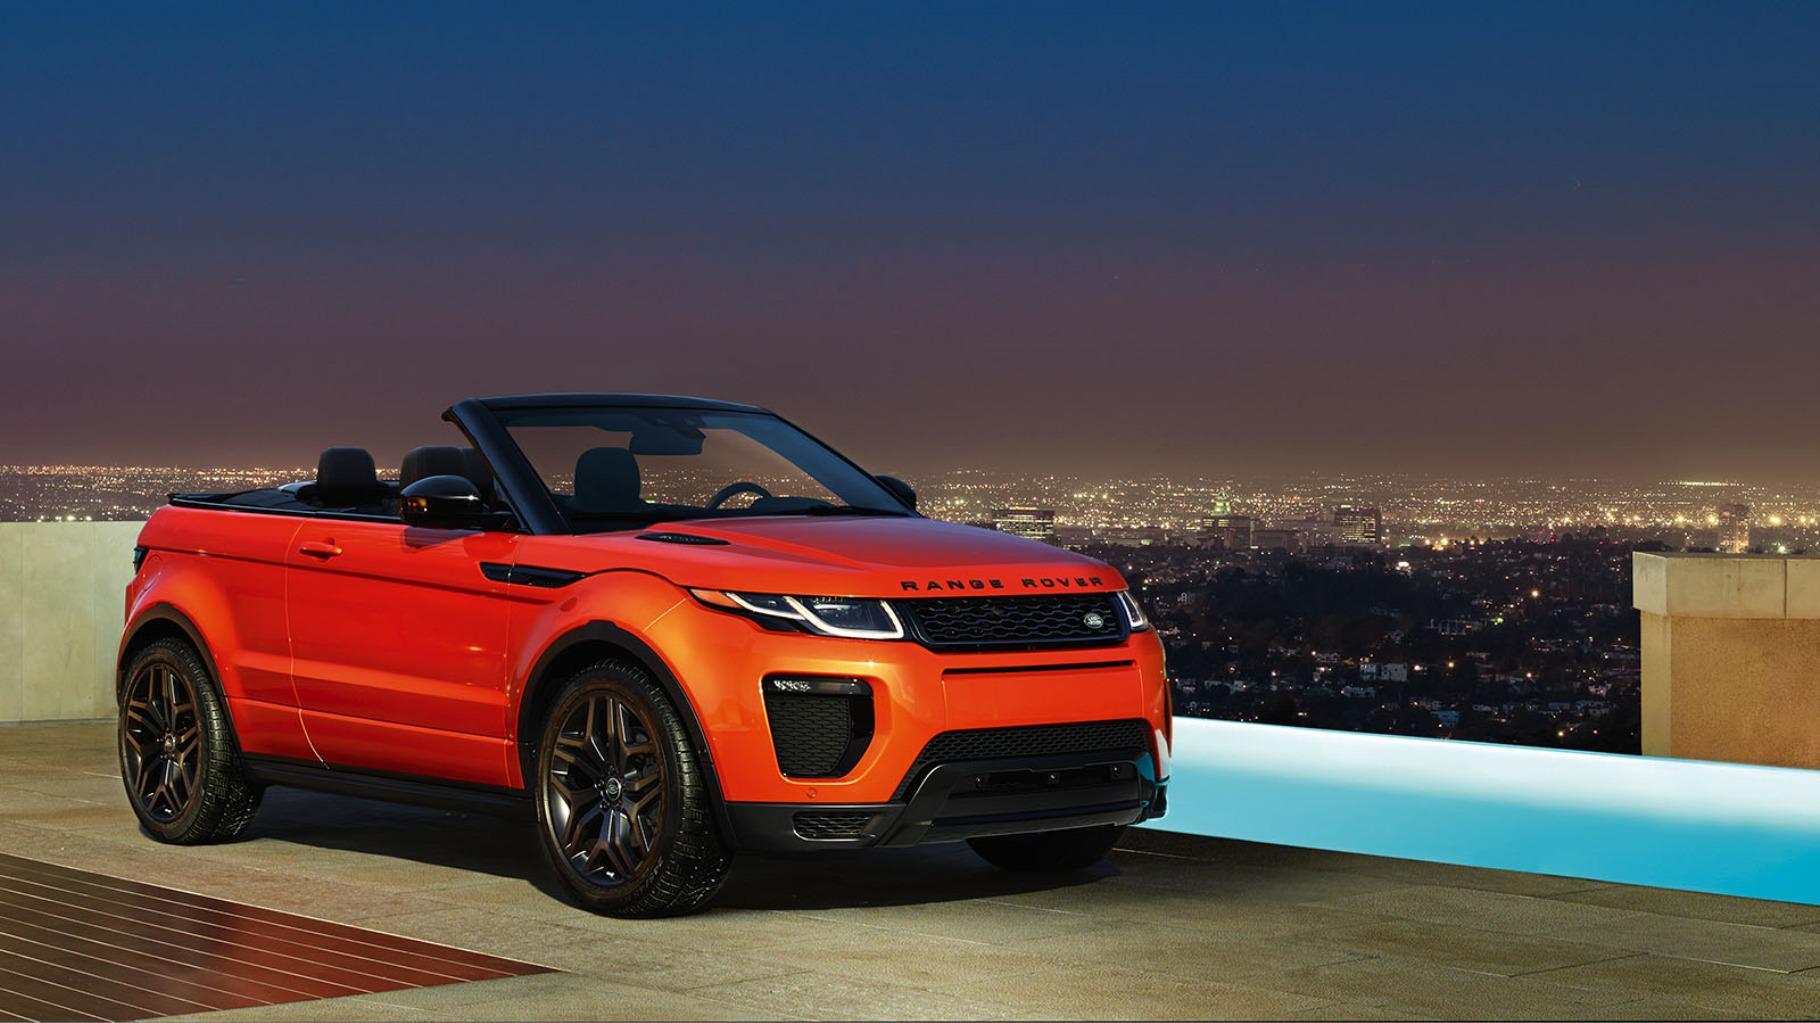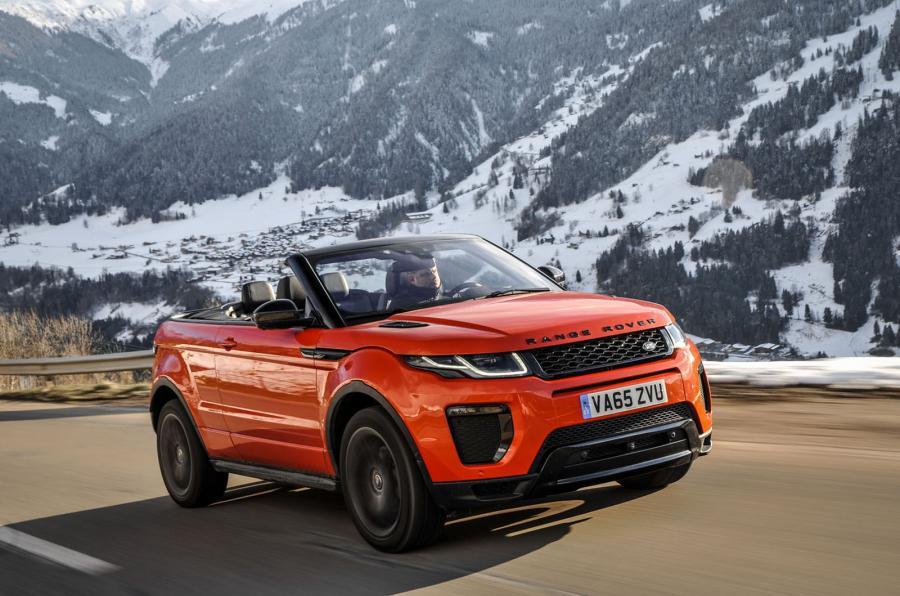The first image is the image on the left, the second image is the image on the right. Analyze the images presented: Is the assertion "The car in one of the images is driving near a snowy location." valid? Answer yes or no. Yes. The first image is the image on the left, the second image is the image on the right. Analyze the images presented: Is the assertion "All cars are topless convertibles, and one car is bright orange while the other is white." valid? Answer yes or no. No. 